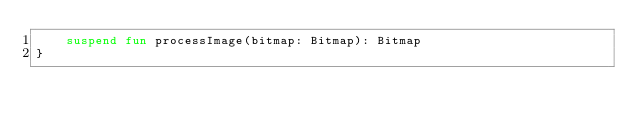Convert code to text. <code><loc_0><loc_0><loc_500><loc_500><_Kotlin_>    suspend fun processImage(bitmap: Bitmap): Bitmap
}
</code> 